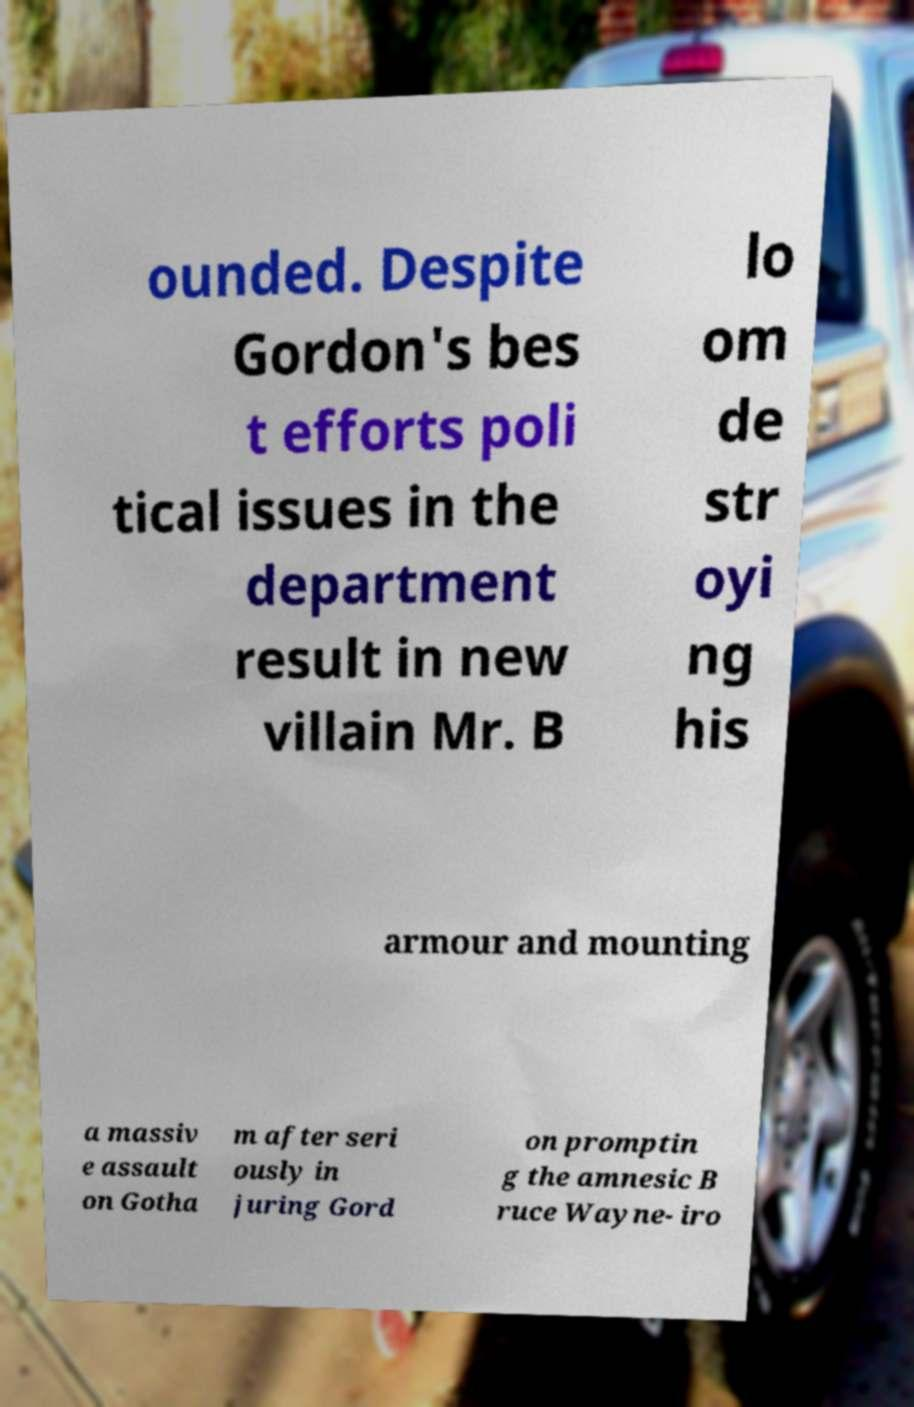Please identify and transcribe the text found in this image. ounded. Despite Gordon's bes t efforts poli tical issues in the department result in new villain Mr. B lo om de str oyi ng his armour and mounting a massiv e assault on Gotha m after seri ously in juring Gord on promptin g the amnesic B ruce Wayne- iro 